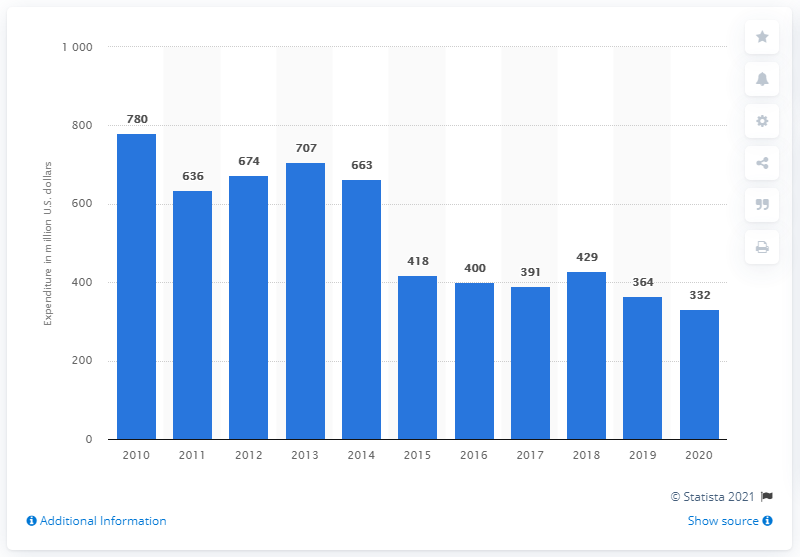Give some essential details in this illustration. BP's research and development spending in the previous year was 364... BP's research and development spending in 2020 was $332 million. 